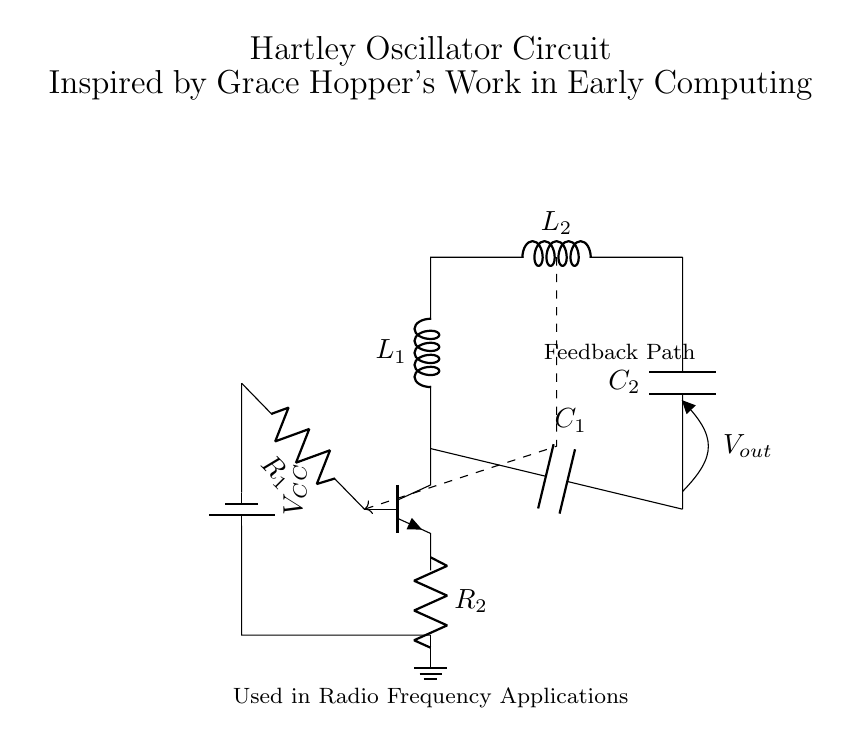What type of oscillator is depicted in the circuit? The circuit shown is a Hartley oscillator, which is characterized by its use of coils and capacitors for generating oscillations.
Answer: Hartley oscillator What components are used for feedback in the Hartley oscillator? The feedback in the Hartley oscillator is provided by the two inductors (coils) L1 and L2 connected to the transistor base, creating a feedback path essential for oscillation.
Answer: L1 and L2 What role does the capacitor C1 play in the circuit? Capacitor C1 is part of the feedback loop and determines the frequency of oscillation along with the inductors. It helps store and release energy, contributing to the oscillation process.
Answer: Frequency determination How is the output voltage represented in the circuit? The output voltage is indicated as Vout and is taken across the capacitor C2, which allows the oscillating output signal to be used in further applications.
Answer: Vout Which component helps provide the operating voltage for the circuit? The battery labeled VCC provides the necessary operating voltage for the circuit, allowing the transistor to function properly and sustain oscillations.
Answer: VCC What is the function of resistor R1 in the Hartley oscillator? Resistor R1 is used to bias the transistor at the appropriate operating point, ensuring stable operation and oscillation frequency by controlling the base current.
Answer: Biasing 